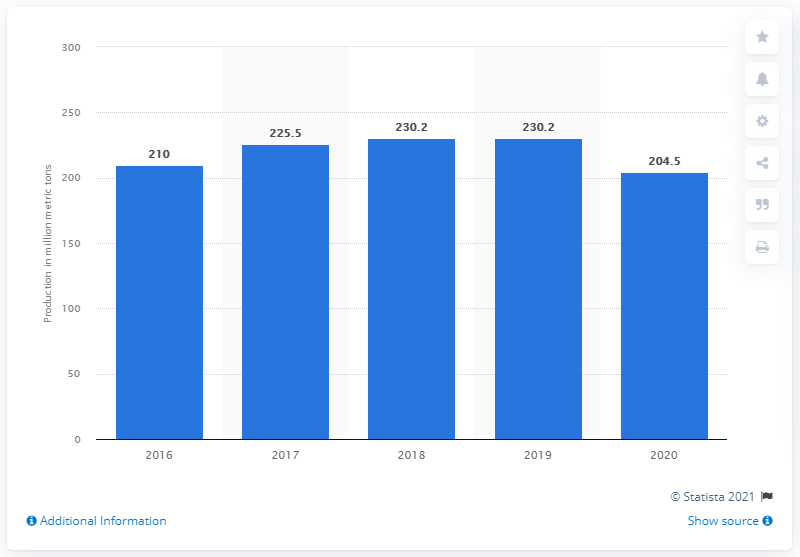Specify some key components in this picture. In 2020, Rosneft produced a total of 204.5 million liquid hydrocarbons. 